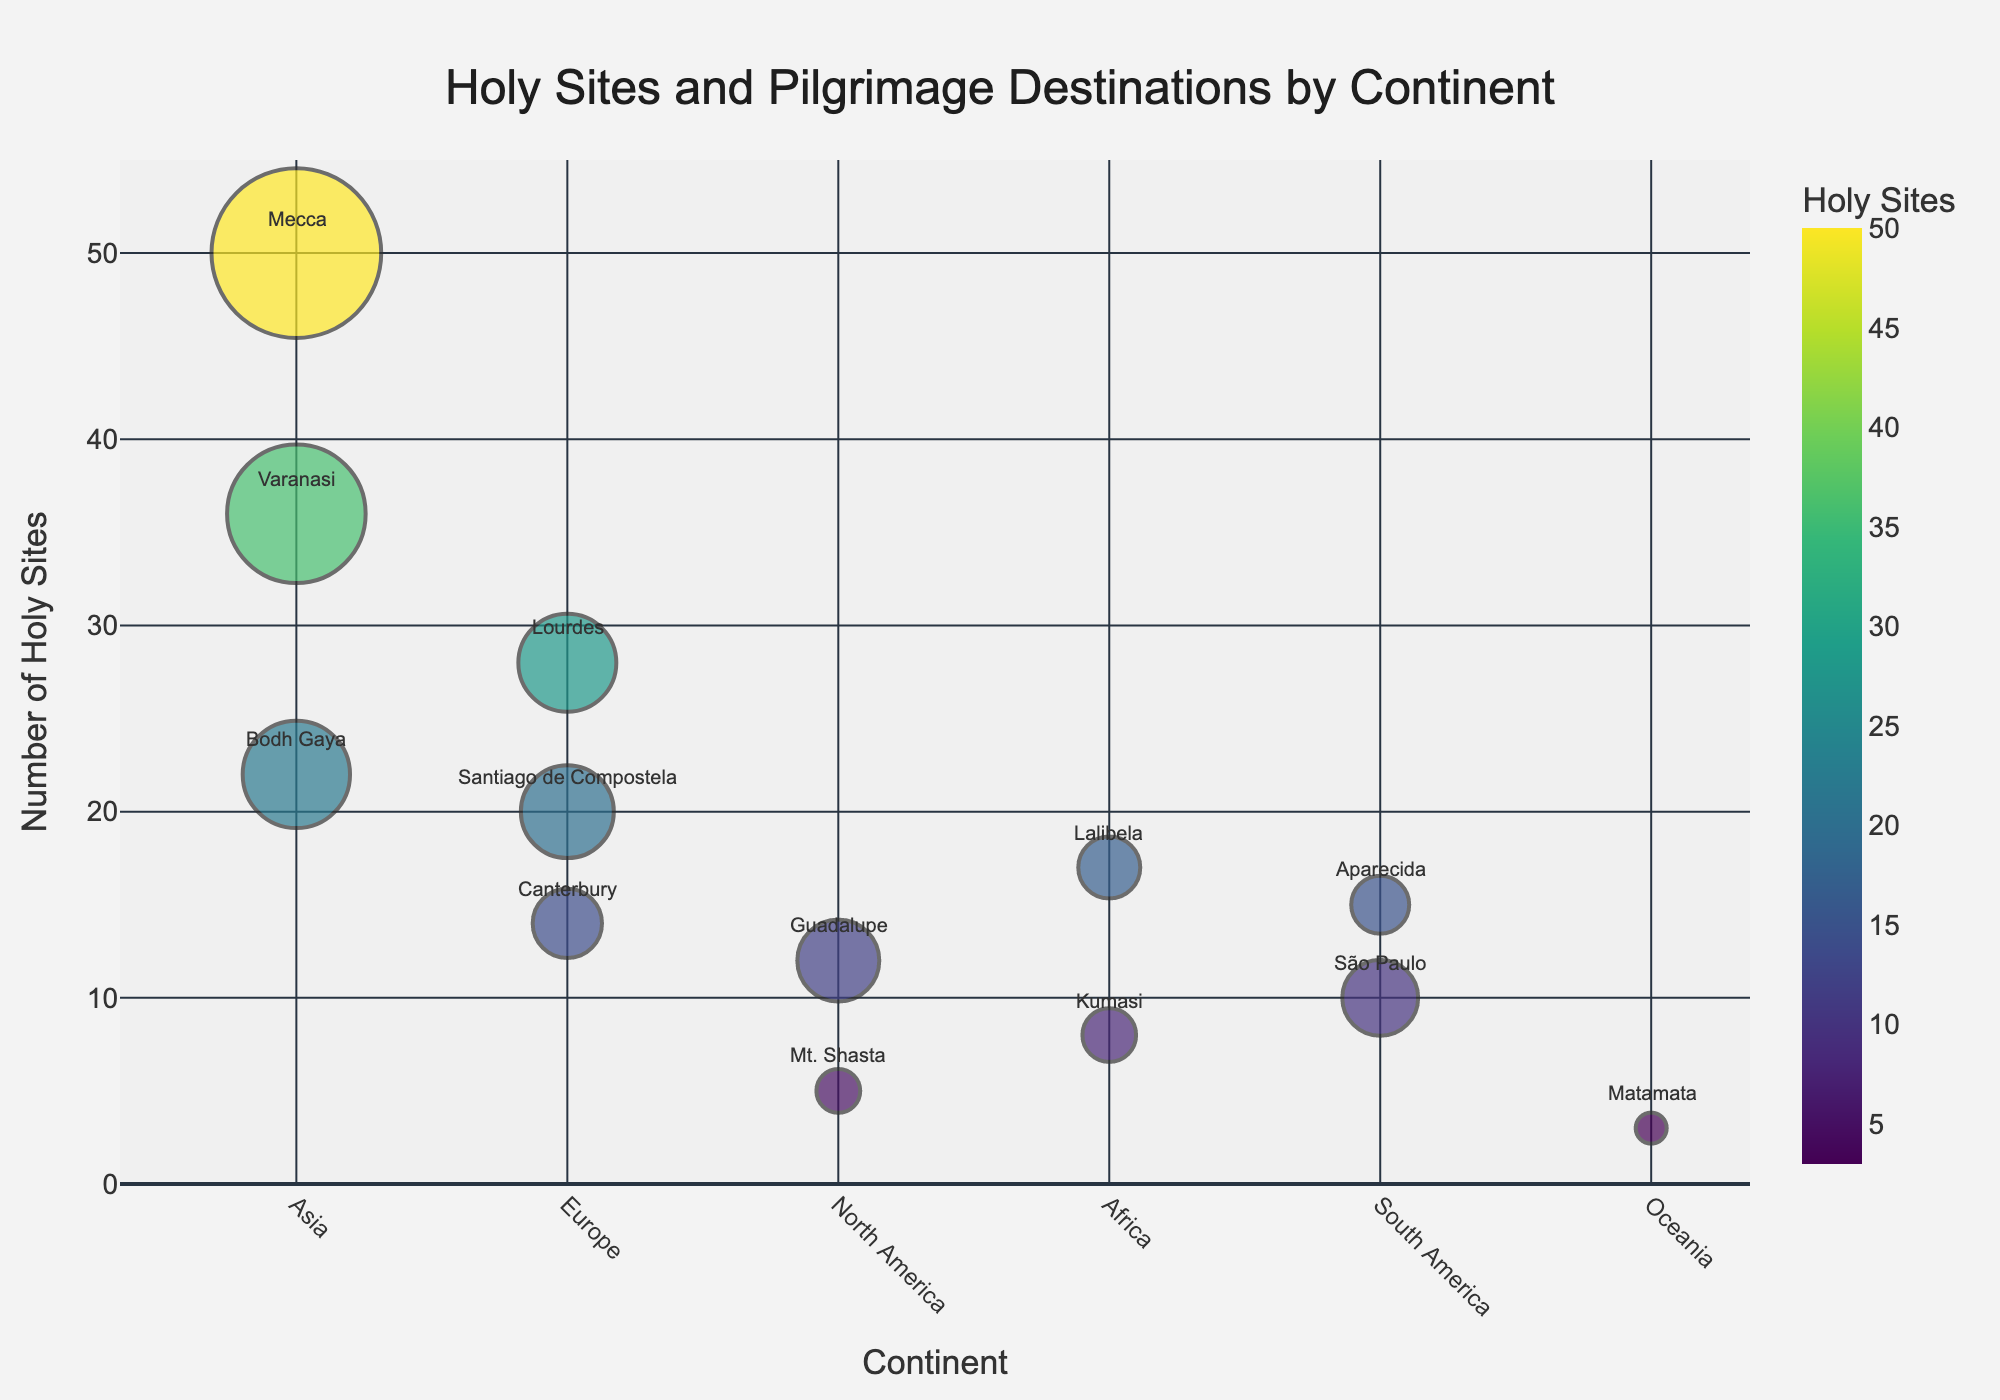Which continent has the highest number of pilgrimage visitors for a single site? By looking at the size of the bubbles, Mecca in Asia has the largest bubble for pilgrimage visitors.
Answer: Asia How many holy sites are listed in Europe on the figure? There are three bubble markers in Europe: Canterbury, Lourdes, and Santiago de Compostela.
Answer: 3 Which location has the fewest holy sites, and how many visitors does it attract? The smallest bubble is in Oceania for Matamata with 3 holy sites and 100 thousand visitors.
Answer: Matamata, 100 What is the total number of holy sites in Asia represented in the figure? Adding up the holy sites from Varanasi, Bodh Gaya, and Mecca in Asia: 36 + 22 + 50 = 108.
Answer: 108 Which continent has the highest average number of holy sites per location? Calculate the averages: 
Asia: (36 + 22 + 50) / 3 = 36
Europe: (14 + 28 + 20) / 3 = 20.67
North America: (12 + 5) / 2 = 8.5
Africa: (17 + 8) / 2 = 12.5
South America: (10 + 15) / 2 = 12.5
Oceania: 3 / 1 = 3
Thus, Asia has the highest average.
Answer: Asia Which location in South America has fewer visitors: São Paulo or Aparecida? Comparing the sizes of the bubbles, São Paulo has 600 thousand visitors and Aparecida has 350 thousand visitors. São Paulo has more visitors, so Aparecida has fewer.
Answer: Aparecida How many continents have locations with more than 20 holy sites? Asia has Varanasi and Mecca (both with more than 20); Europe has Lourdes (28). Only two continents meet this criterion.
Answer: 2 Which location in North America has more holy sites, Guadalupe or Mt. Shasta, and by how many? Guadalupe has 12 holy sites, and Mt. Shasta has 5. The difference is 12 - 5 = 7.
Answer: Guadalupe, by 7 Compare the total number of holy sites in Europe to those in Africa. Which has more and by how much? Europe: 14 (Canterbury) + 28 (Lourdes) + 20 (Santiago de Compostela) = 62
Africa: 17 (Lalibela) + 8 (Kumasi) = 25
Europe has more by 62 - 25 = 37.
Answer: Europe, by 37 